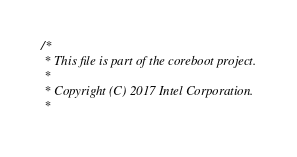Convert code to text. <code><loc_0><loc_0><loc_500><loc_500><_C_>/*
 * This file is part of the coreboot project.
 *
 * Copyright (C) 2017 Intel Corporation.
 *</code> 